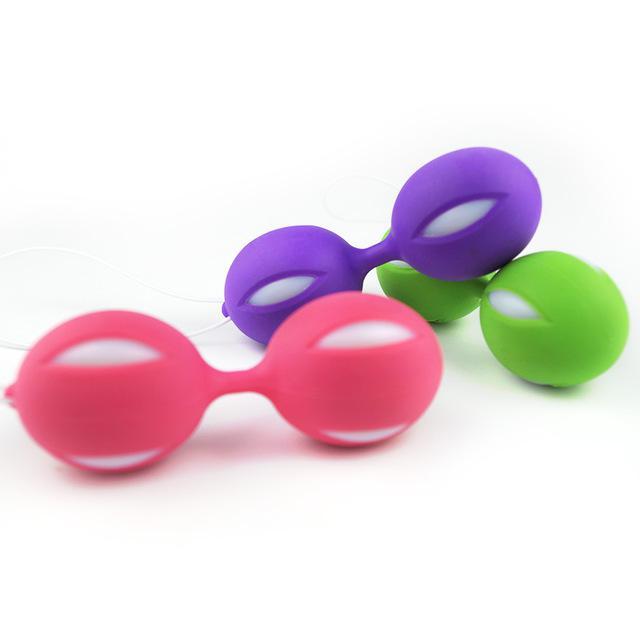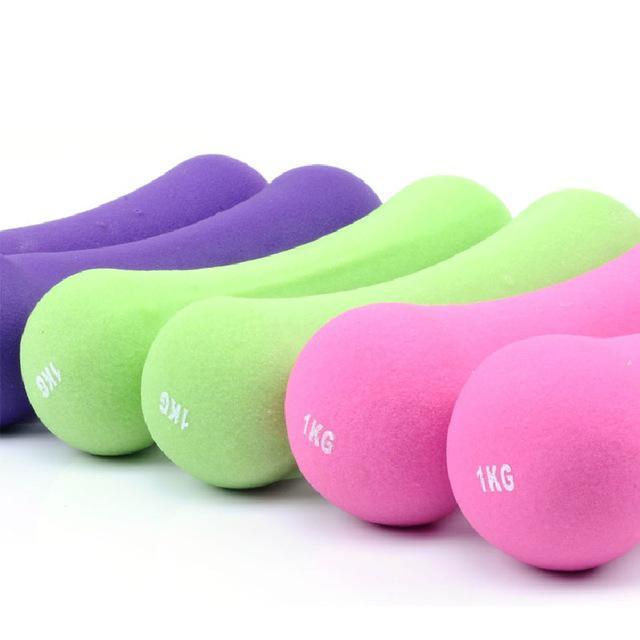The first image is the image on the left, the second image is the image on the right. Given the left and right images, does the statement "The left and right image contains the a total of eight weights." hold true? Answer yes or no. No. The first image is the image on the left, the second image is the image on the right. For the images shown, is this caption "One image contains two each of three different colors of barbell-shaped weights." true? Answer yes or no. Yes. 